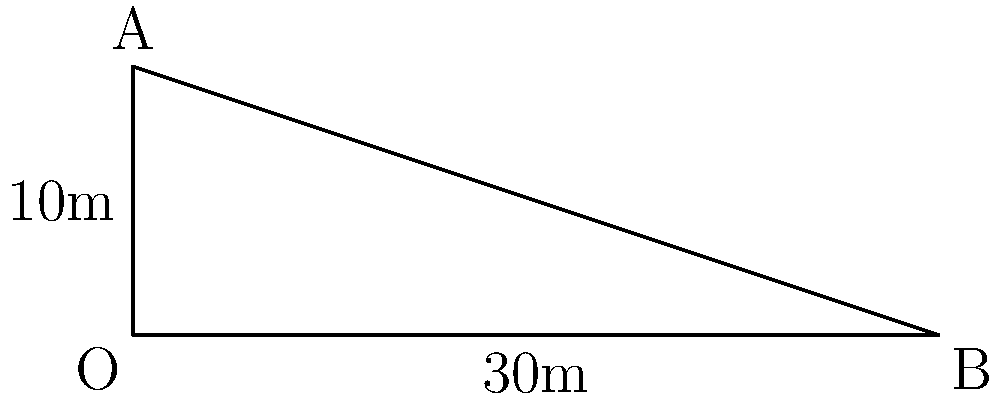During a crucial conversion kick for the New Zealand Warriors, the kicker aims to clear the crossbar at point A, which is 10 meters high. If the ball is kicked from point O and travels in a straight line to just clear the crossbar at A before landing 30 meters away at point B, what is the angle $\theta$ (in degrees) at which the ball must be kicked? Let's approach this step-by-step:

1) We have a right-angled triangle OAB, where:
   - OA is the height of the crossbar (10 meters)
   - OB is the distance the ball travels horizontally (30 meters)
   - Angle $\theta$ at O is what we need to find

2) In a right-angled triangle, tan(θ) is the ratio of the opposite side to the adjacent side:

   $$\tan(\theta) = \frac{\text{opposite}}{\text{adjacent}} = \frac{OA}{OB} = \frac{10}{30}$$

3) Simplify the fraction:

   $$\tan(\theta) = \frac{1}{3}$$

4) To find $\theta$, we need to use the inverse tangent (arctan or $\tan^{-1}$):

   $$\theta = \tan^{-1}(\frac{1}{3})$$

5) Using a calculator or trigonometric tables:

   $$\theta \approx 18.43^\circ$$

6) Round to two decimal places:

   $$\theta \approx 18.43^\circ$$

Therefore, the kicker must kick the ball at an angle of approximately 18.43° to clear the crossbar and land 30 meters away.
Answer: 18.43° 